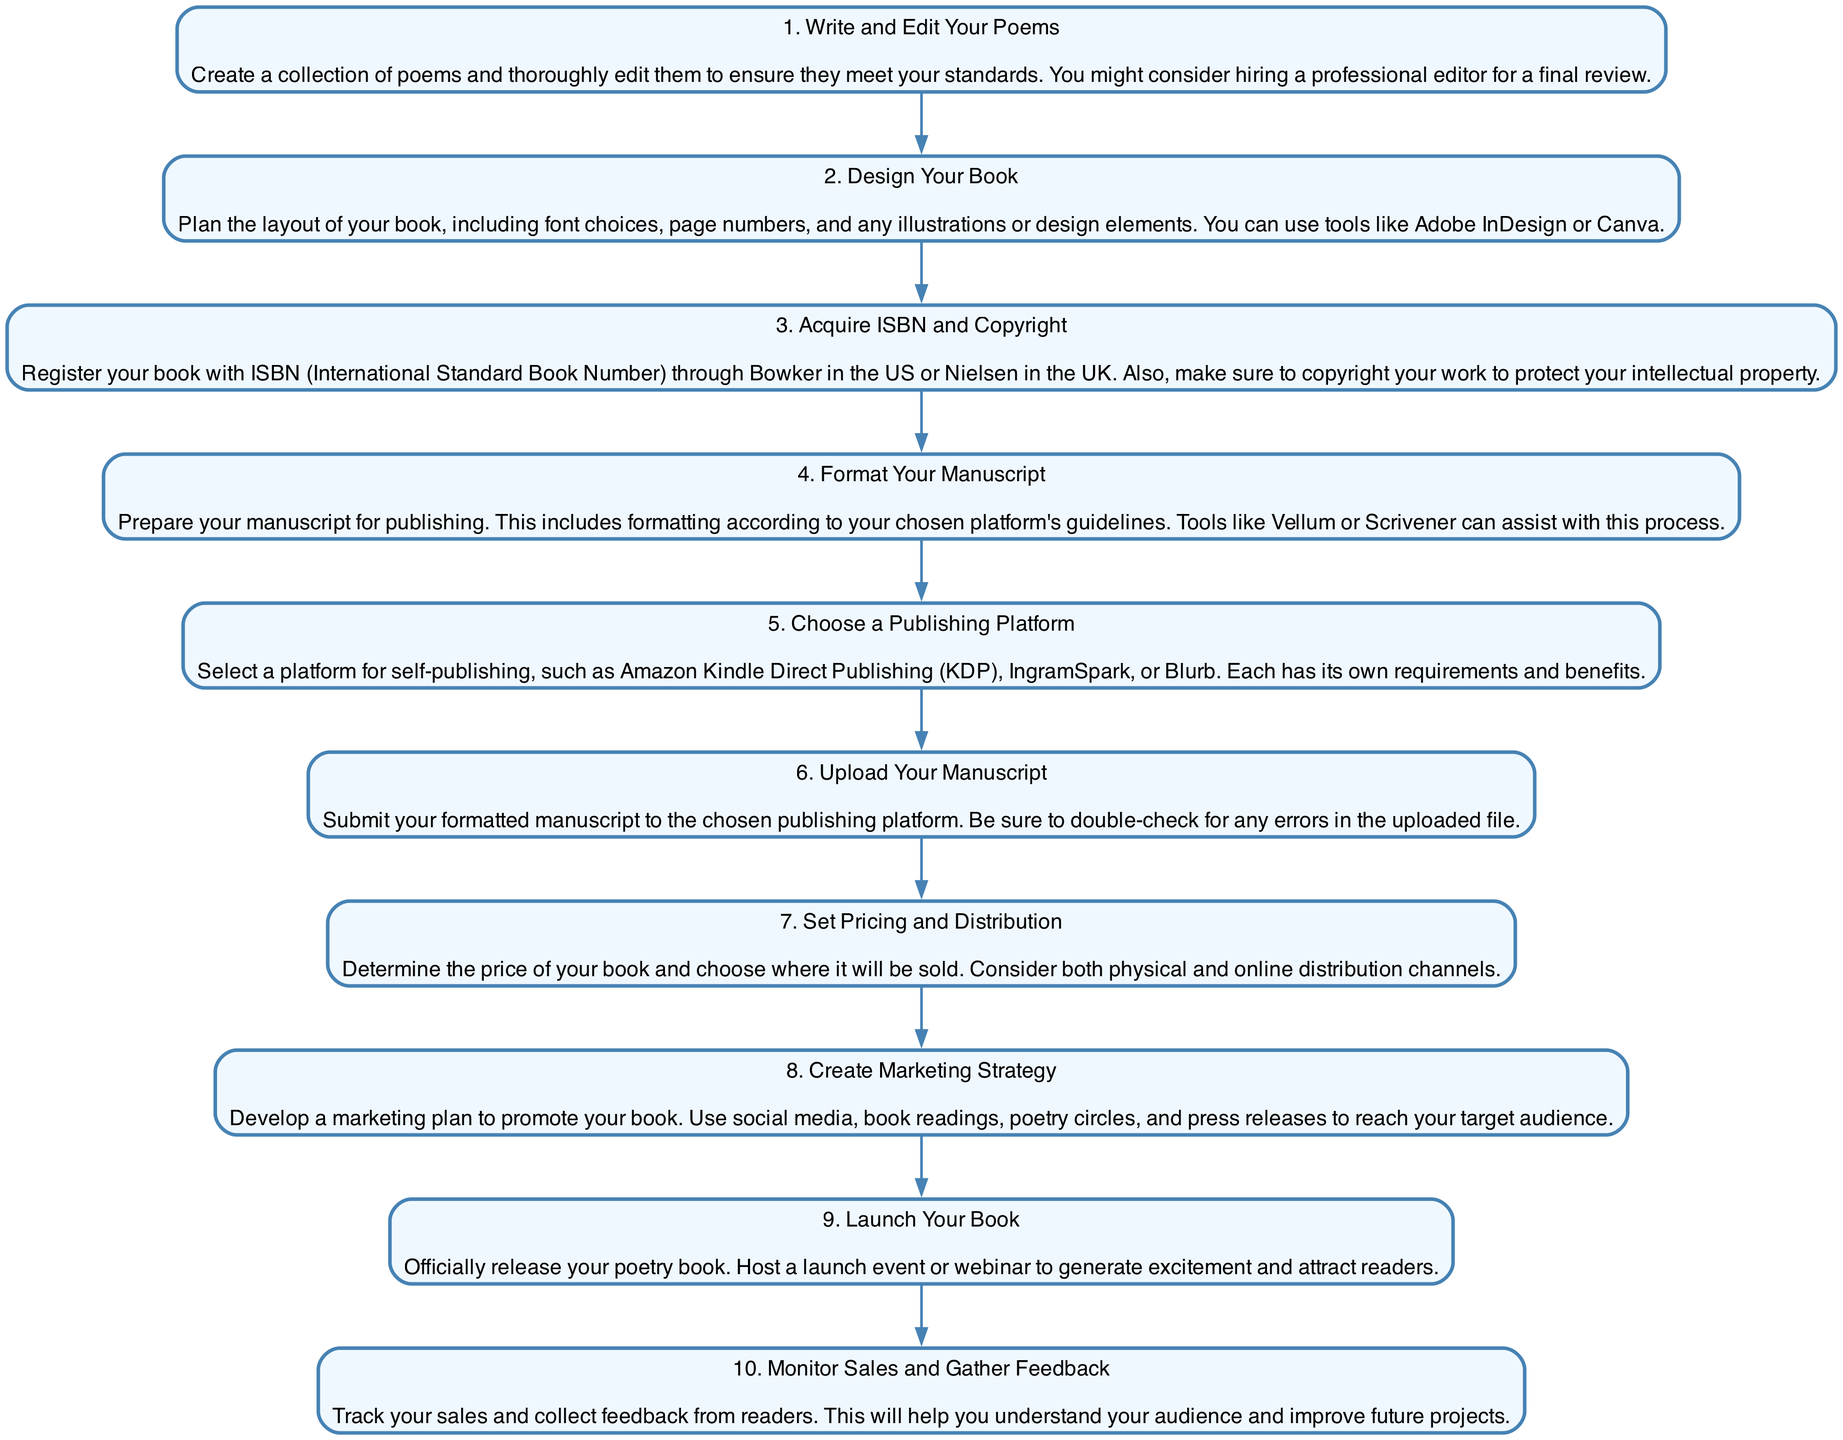What is the first step in self-publishing a poetry book? The first step, as indicated in the diagram, is "Write and Edit Your Poems." This means that the process starts with creating a collection of poems and thoroughly editing them.
Answer: Write and Edit Your Poems How many total steps are there in the self-publishing process? The diagram shows a list numbered from 1 to 10, indicating that there are a total of ten steps in the self-publishing process.
Answer: 10 What is the title of the last step? The last step in the diagram is assigned the number 10 and titled "Monitor Sales and Gather Feedback." This gives a clear indication of what the final action entails.
Answer: Monitor Sales and Gather Feedback Which step involves designing the layout? The step that involves designing the layout of the book is step 2, titled "Design Your Book." According to the diagram, this step includes planning font choices and any design elements.
Answer: Design Your Book What is the immediate next step after "Acquire ISBN and Copyright"? The diagram indicates that after step 3 "Acquire ISBN and Copyright," the next immediate step is step 4, labeled "Format Your Manuscript." This clearly shows the sequential nature of the steps.
Answer: Format Your Manuscript What actions are included in step 8? Step 8 is titled "Create Marketing Strategy," which signifies developing a marketing plan using social media and other promotional methods as described in the diagram. This indicates what actions should be taken.
Answer: Create Marketing Strategy How do you protect your intellectual property? To protect intellectual property, one must "Copyright your work," as stated in step 3, which is crucial in securing the rights to their poetry.
Answer: Copyright your work In which step do you set the pricing and distribution? Pricing and distribution are addressed in step 7, which clearly instructs to determine the price of the book and where it will be sold.
Answer: Set Pricing and Distribution What are the tools mentioned for formatting your manuscript? The diagram lists tools like "Vellum or Scrivener" for preparing the manuscript for publishing. These are highlighted in step 4 as options to assist with the formatting process.
Answer: Vellum or Scrivener 